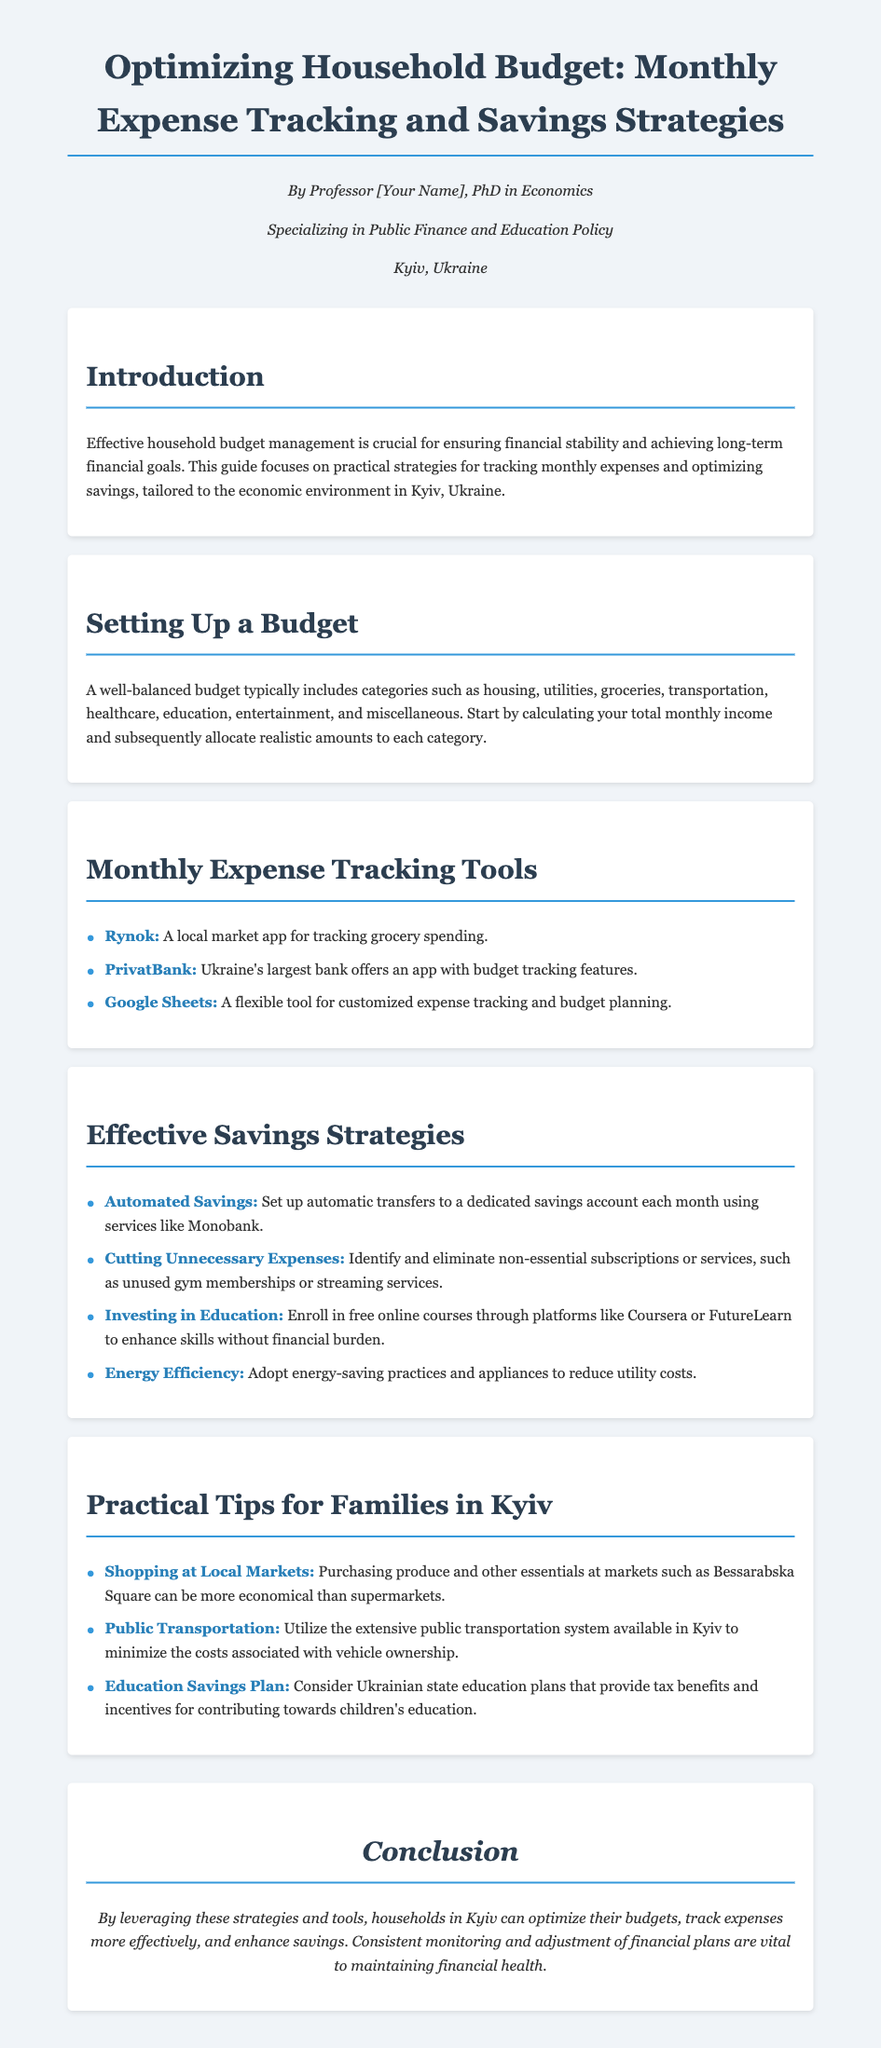What is the title of the user guide? The title of the user guide is clearly stated at the top of the document.
Answer: Optimizing Household Budget: Monthly Expense Tracking and Savings Strategies Who is the author of the guide? The author of the guide is mentioned in the author info section at the beginning.
Answer: Professor [Your Name] What are the main categories of a well-balanced budget? The document lists several categories for a well-balanced budget in the section on setting up a budget.
Answer: Housing, utilities, groceries, transportation, healthcare, education, entertainment, and miscellaneous Which app is mentioned for tracking grocery spending? The document provides examples of tools for monthly expense tracking, including specific apps.
Answer: Rynok What is one effective savings strategy mentioned? The document outlines multiple savings strategies under the effective savings strategies section.
Answer: Automated Savings What tip is provided for families regarding local markets? The document offers practical tips for families, specifically mentioning local markets.
Answer: Shopping at Local Markets How can public transportation help with budgeting? The practical tips section discusses the significance of public transportation in relation to costs.
Answer: Minimize costs associated with vehicle ownership What educational resource is suggested for skill enhancement? The document recommends a platform for online learning that can enhance skills without financial burden.
Answer: Coursera Which bank's app offers budget tracking features? The monthly expense tracking tools section mentions a specific bank that offers an app for tracking budgets.
Answer: PrivatBank 